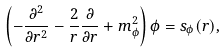<formula> <loc_0><loc_0><loc_500><loc_500>\left ( - \frac { \partial ^ { 2 } } { \partial r ^ { 2 } } - \frac { 2 } { r } \frac { \partial } { \partial r } + m _ { \phi } ^ { 2 } \right ) \phi = s _ { \phi } ( r ) ,</formula> 